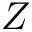Convert formula to latex. <formula><loc_0><loc_0><loc_500><loc_500>Z</formula> 